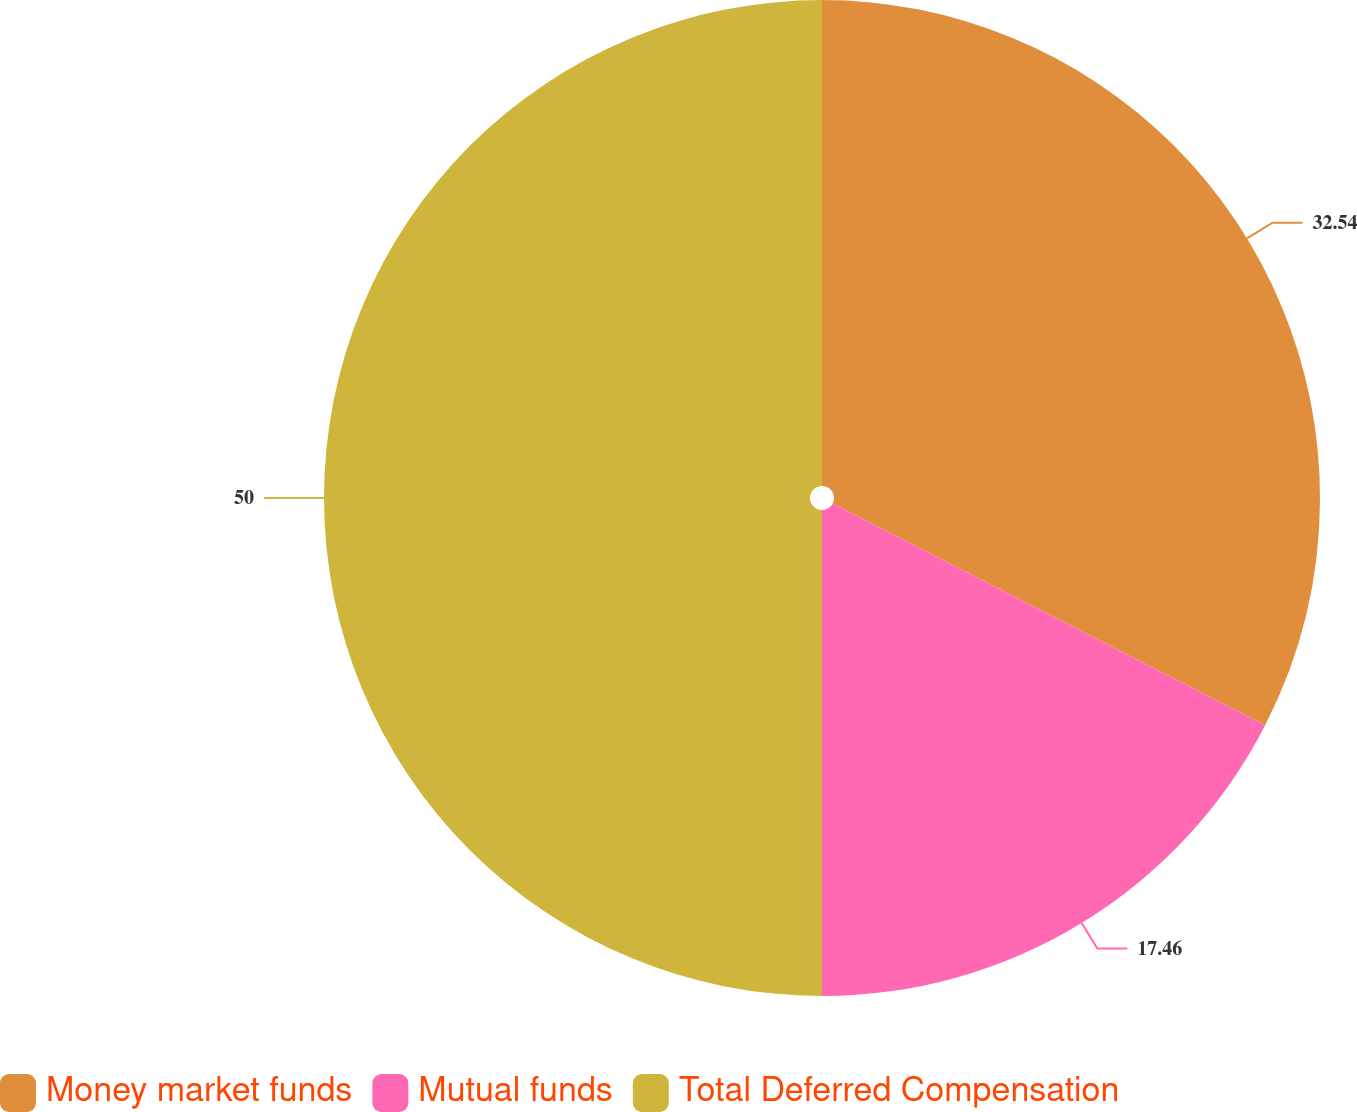Convert chart to OTSL. <chart><loc_0><loc_0><loc_500><loc_500><pie_chart><fcel>Money market funds<fcel>Mutual funds<fcel>Total Deferred Compensation<nl><fcel>32.54%<fcel>17.46%<fcel>50.0%<nl></chart> 